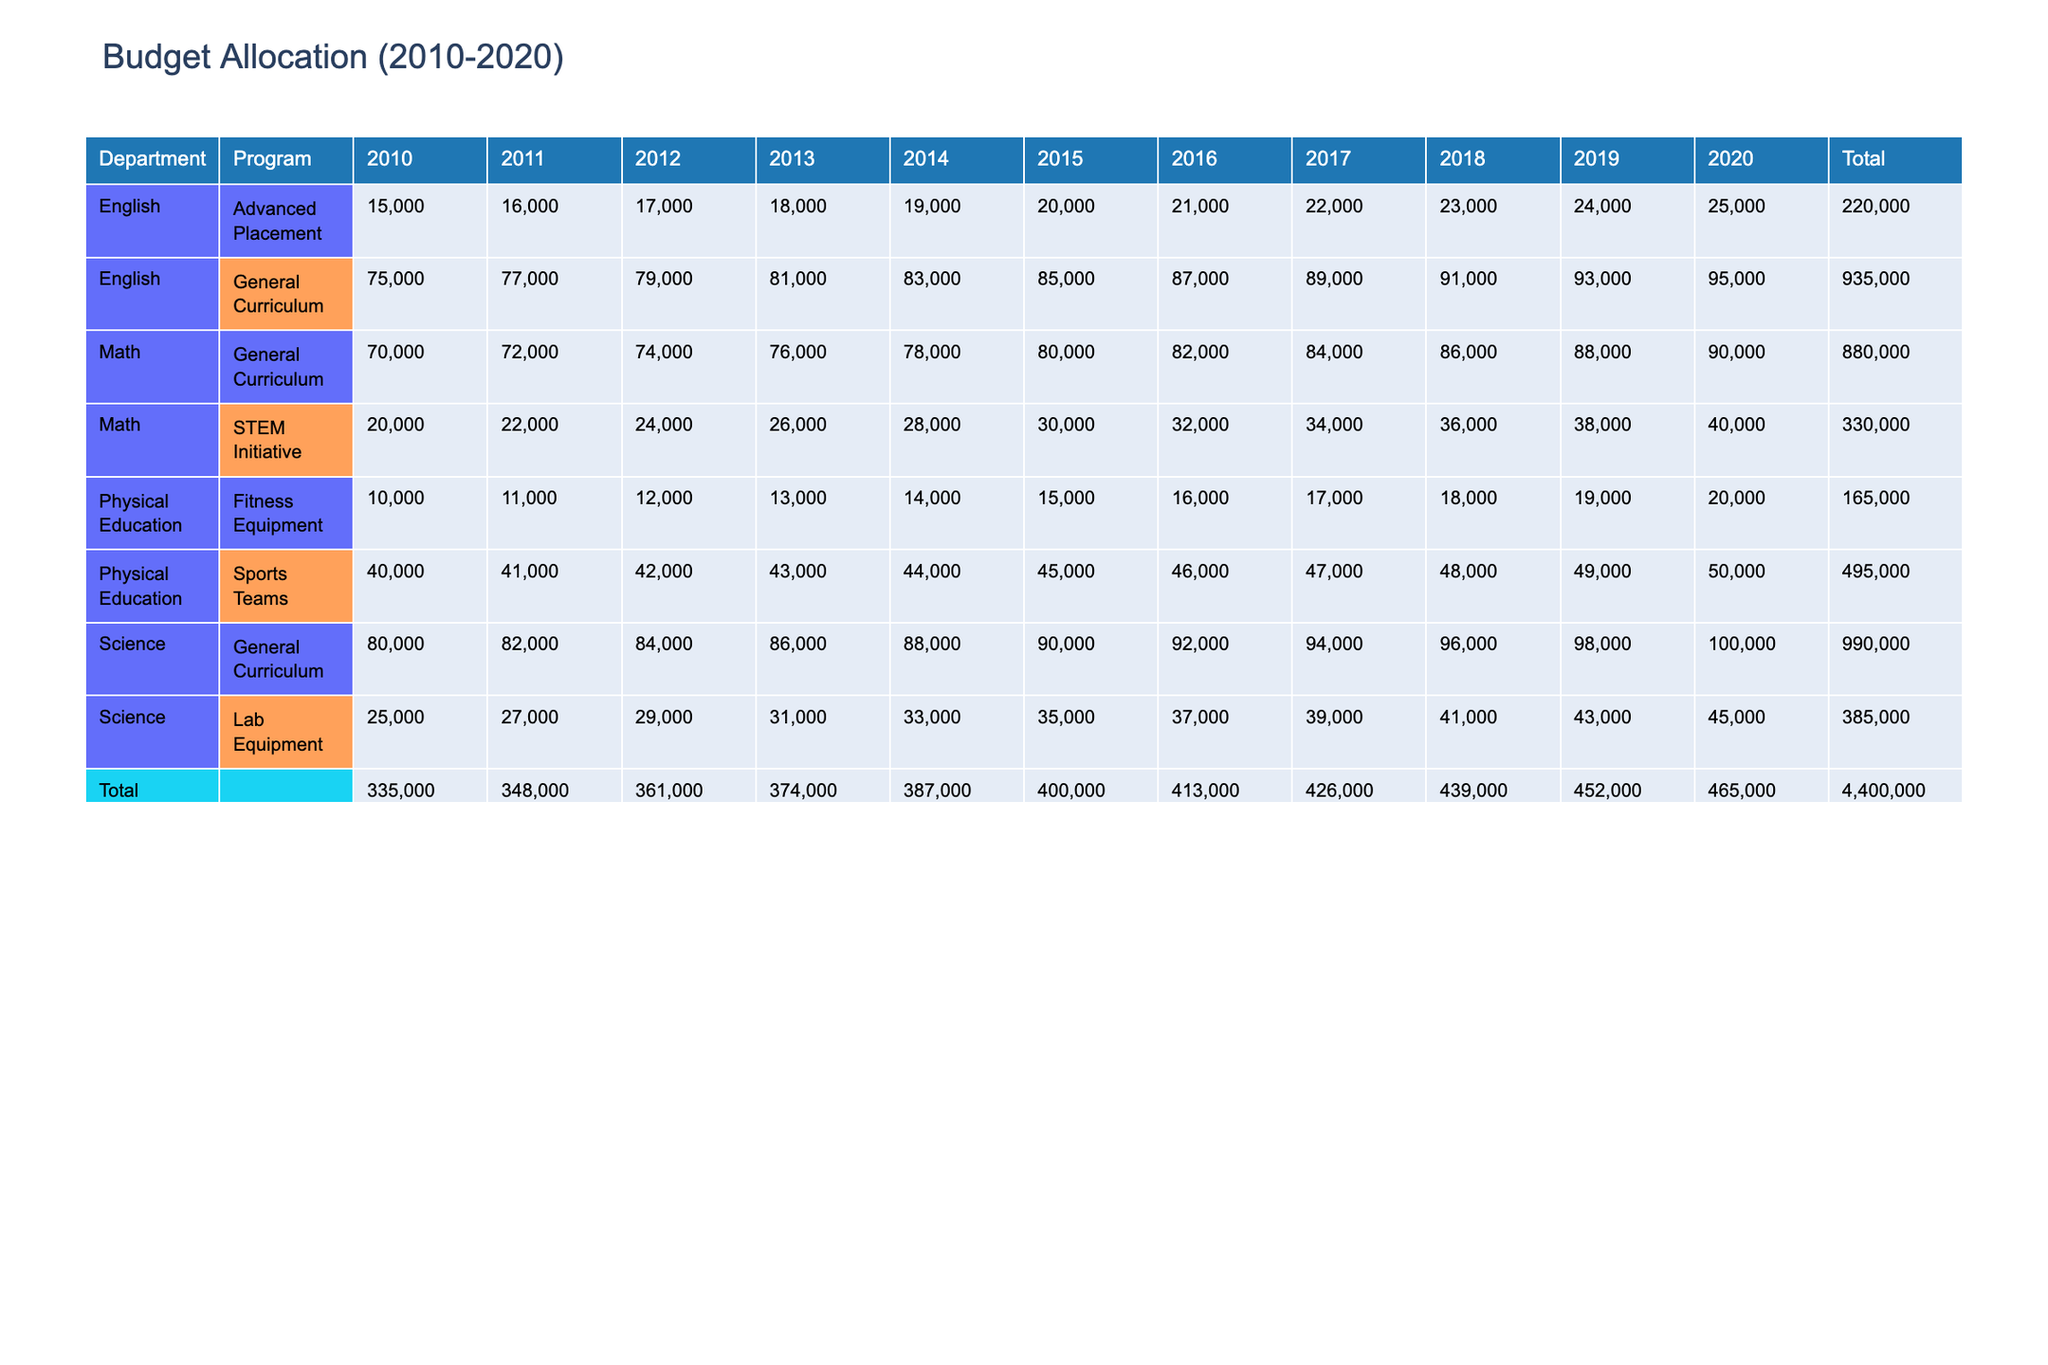What is the total budget allocated to the Science department in 2017? In 2017, the Science department has two programs listed: General Curriculum ($94,000) and Lab Equipment ($39,000). Adding these two values together gives us $94,000 + $39,000 = $133,000.
Answer: 133000 Which program in the English department has the highest budget allocation in 2019? In 2019, the English department has two programs: General Curriculum with a budget of $93,000 and Advanced Placement with a budget of $24,000. The General Curriculum has the higher budget of the two.
Answer: General Curriculum What was the overall percentage increase in the Physical Education budget from 2010 to 2020? In 2010, the total budget for Physical Education was $50,000 ($40,000 for Sports Teams and $10,000 for Fitness Equipment). In 2020, it was $70,000 ($50,000 for Sports Teams and $20,000 for Fitness Equipment). The increase is $70,000 - $50,000 = $20,000. To find the percentage increase, divide the increase by the original amount: ($20,000 / $50,000) * 100 = 40%.
Answer: 40% Did the total budget for the Math department exceed $300,000 in 2015? In 2015, the budget for the Math department consists of two programs: General Curriculum ($80,000) and STEM Initiative ($30,000). Adding these gives us $80,000 + $30,000 = $110,000. As this value is below $300,000, the answer is no.
Answer: No What is the average budget allocated to the Science department from 2010 to 2020? The total budget for the Science department needs to be summed for each year from 2010 to 2020. The budgets for each year are: 107,000 (2010) + 107,000 (2011) + 113,000 (2012) + 119,000 (2013) + 125,000 (2014) + 130,000 (2015) + 137,000 (2016) + 143,000 (2017) + 150,000 (2018) + 153,000 (2019) + 155,000 (2020) = 1,464,000. There are 11 data points (years) and the average is 1,464,000 / 11 = 132,182.
Answer: 132182 What was the total budget for Advanced Placement across all years? The Advanced Placement budget entries are: $15,000 (2010) + $16,000 (2011) + $17,000 (2012) + $18,000 (2013) + $19,000 (2014) + $20,000 (2015) + $21,000 (2016) + $22,000 (2017) + $23,000 (2018) + $24,000 (2019) + $25,000 (2020). Adding all these values gives $15,000 + 16,000 + 17,000 + 18,000 + 19,000 + 20,000 + 21,000 + 22,000 + 23,000 + 24,000 + 25,000 = 210,000.
Answer: 210000 